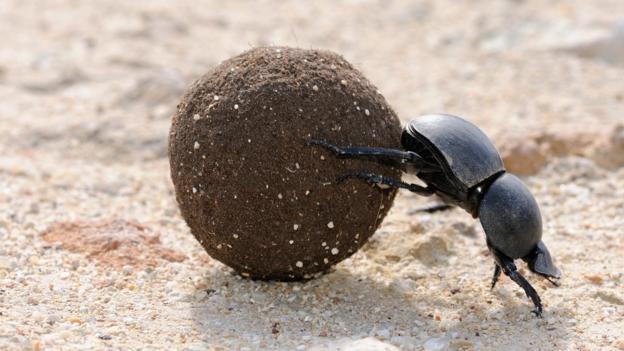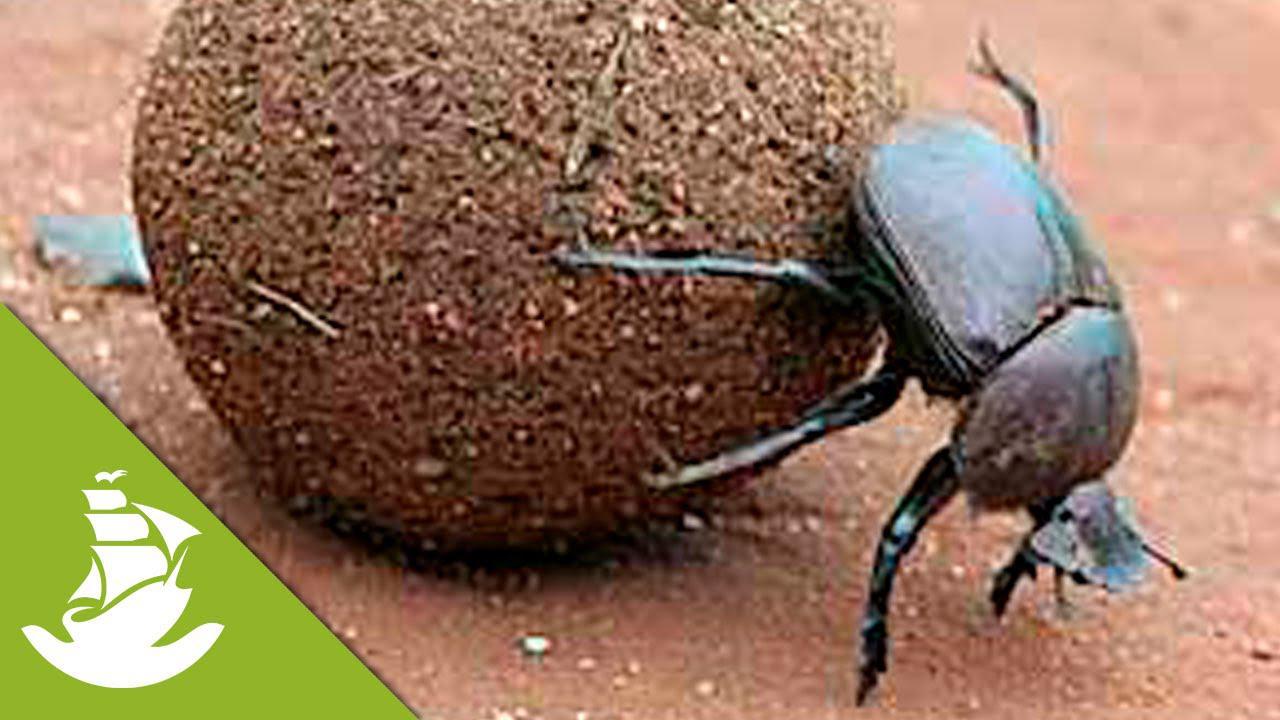The first image is the image on the left, the second image is the image on the right. For the images shown, is this caption "Each image has at least 2 dung beetles with a ball of dung." true? Answer yes or no. No. The first image is the image on the left, the second image is the image on the right. Analyze the images presented: Is the assertion "There are two dung beetles." valid? Answer yes or no. Yes. 